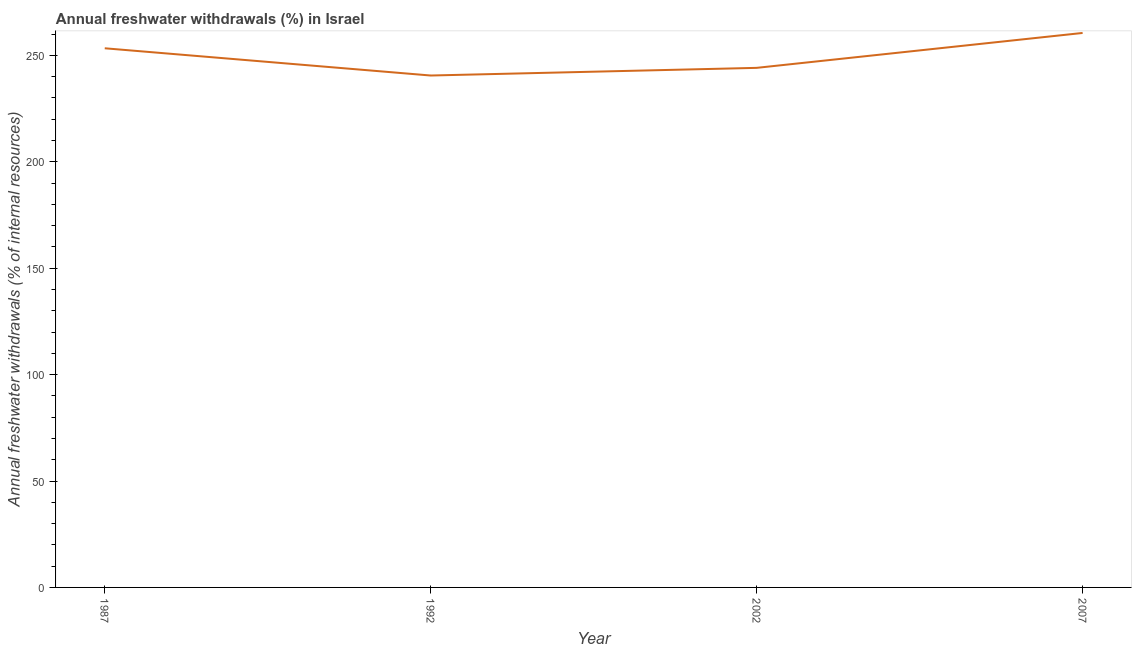What is the annual freshwater withdrawals in 1992?
Make the answer very short. 240.53. Across all years, what is the maximum annual freshwater withdrawals?
Your response must be concise. 260.53. Across all years, what is the minimum annual freshwater withdrawals?
Keep it short and to the point. 240.53. In which year was the annual freshwater withdrawals maximum?
Give a very brief answer. 2007. What is the sum of the annual freshwater withdrawals?
Your response must be concise. 998.53. What is the difference between the annual freshwater withdrawals in 2002 and 2007?
Provide a succinct answer. -16.4. What is the average annual freshwater withdrawals per year?
Your answer should be very brief. 249.63. What is the median annual freshwater withdrawals?
Make the answer very short. 248.73. Do a majority of the years between 1987 and 2007 (inclusive) have annual freshwater withdrawals greater than 140 %?
Your answer should be compact. Yes. What is the ratio of the annual freshwater withdrawals in 2002 to that in 2007?
Provide a short and direct response. 0.94. Is the annual freshwater withdrawals in 2002 less than that in 2007?
Provide a succinct answer. Yes. Is the difference between the annual freshwater withdrawals in 2002 and 2007 greater than the difference between any two years?
Provide a succinct answer. No. What is the difference between the highest and the second highest annual freshwater withdrawals?
Offer a very short reply. 7.2. What is the difference between the highest and the lowest annual freshwater withdrawals?
Provide a short and direct response. 20. In how many years, is the annual freshwater withdrawals greater than the average annual freshwater withdrawals taken over all years?
Provide a short and direct response. 2. Does the annual freshwater withdrawals monotonically increase over the years?
Give a very brief answer. No. How many lines are there?
Provide a short and direct response. 1. How many years are there in the graph?
Your response must be concise. 4. What is the difference between two consecutive major ticks on the Y-axis?
Your answer should be compact. 50. Are the values on the major ticks of Y-axis written in scientific E-notation?
Your answer should be compact. No. Does the graph contain any zero values?
Keep it short and to the point. No. Does the graph contain grids?
Provide a short and direct response. No. What is the title of the graph?
Give a very brief answer. Annual freshwater withdrawals (%) in Israel. What is the label or title of the X-axis?
Ensure brevity in your answer.  Year. What is the label or title of the Y-axis?
Your response must be concise. Annual freshwater withdrawals (% of internal resources). What is the Annual freshwater withdrawals (% of internal resources) in 1987?
Give a very brief answer. 253.33. What is the Annual freshwater withdrawals (% of internal resources) in 1992?
Ensure brevity in your answer.  240.53. What is the Annual freshwater withdrawals (% of internal resources) of 2002?
Your response must be concise. 244.13. What is the Annual freshwater withdrawals (% of internal resources) of 2007?
Offer a terse response. 260.53. What is the difference between the Annual freshwater withdrawals (% of internal resources) in 1987 and 2002?
Provide a short and direct response. 9.2. What is the difference between the Annual freshwater withdrawals (% of internal resources) in 1987 and 2007?
Provide a succinct answer. -7.2. What is the difference between the Annual freshwater withdrawals (% of internal resources) in 2002 and 2007?
Give a very brief answer. -16.4. What is the ratio of the Annual freshwater withdrawals (% of internal resources) in 1987 to that in 1992?
Offer a very short reply. 1.05. What is the ratio of the Annual freshwater withdrawals (% of internal resources) in 1987 to that in 2002?
Keep it short and to the point. 1.04. What is the ratio of the Annual freshwater withdrawals (% of internal resources) in 1992 to that in 2002?
Make the answer very short. 0.98. What is the ratio of the Annual freshwater withdrawals (% of internal resources) in 1992 to that in 2007?
Your answer should be very brief. 0.92. What is the ratio of the Annual freshwater withdrawals (% of internal resources) in 2002 to that in 2007?
Your answer should be very brief. 0.94. 